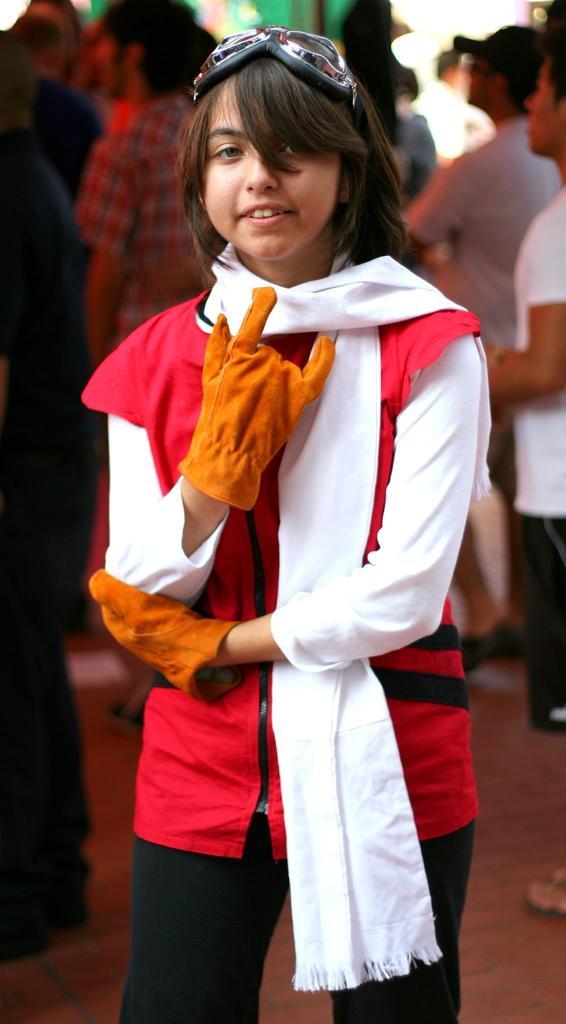Describe this image in one or two sentences. In the image we can see there is a girl standing and she is wearing gloves in her hand and scarf in her neck. Behind there are other people standing. 